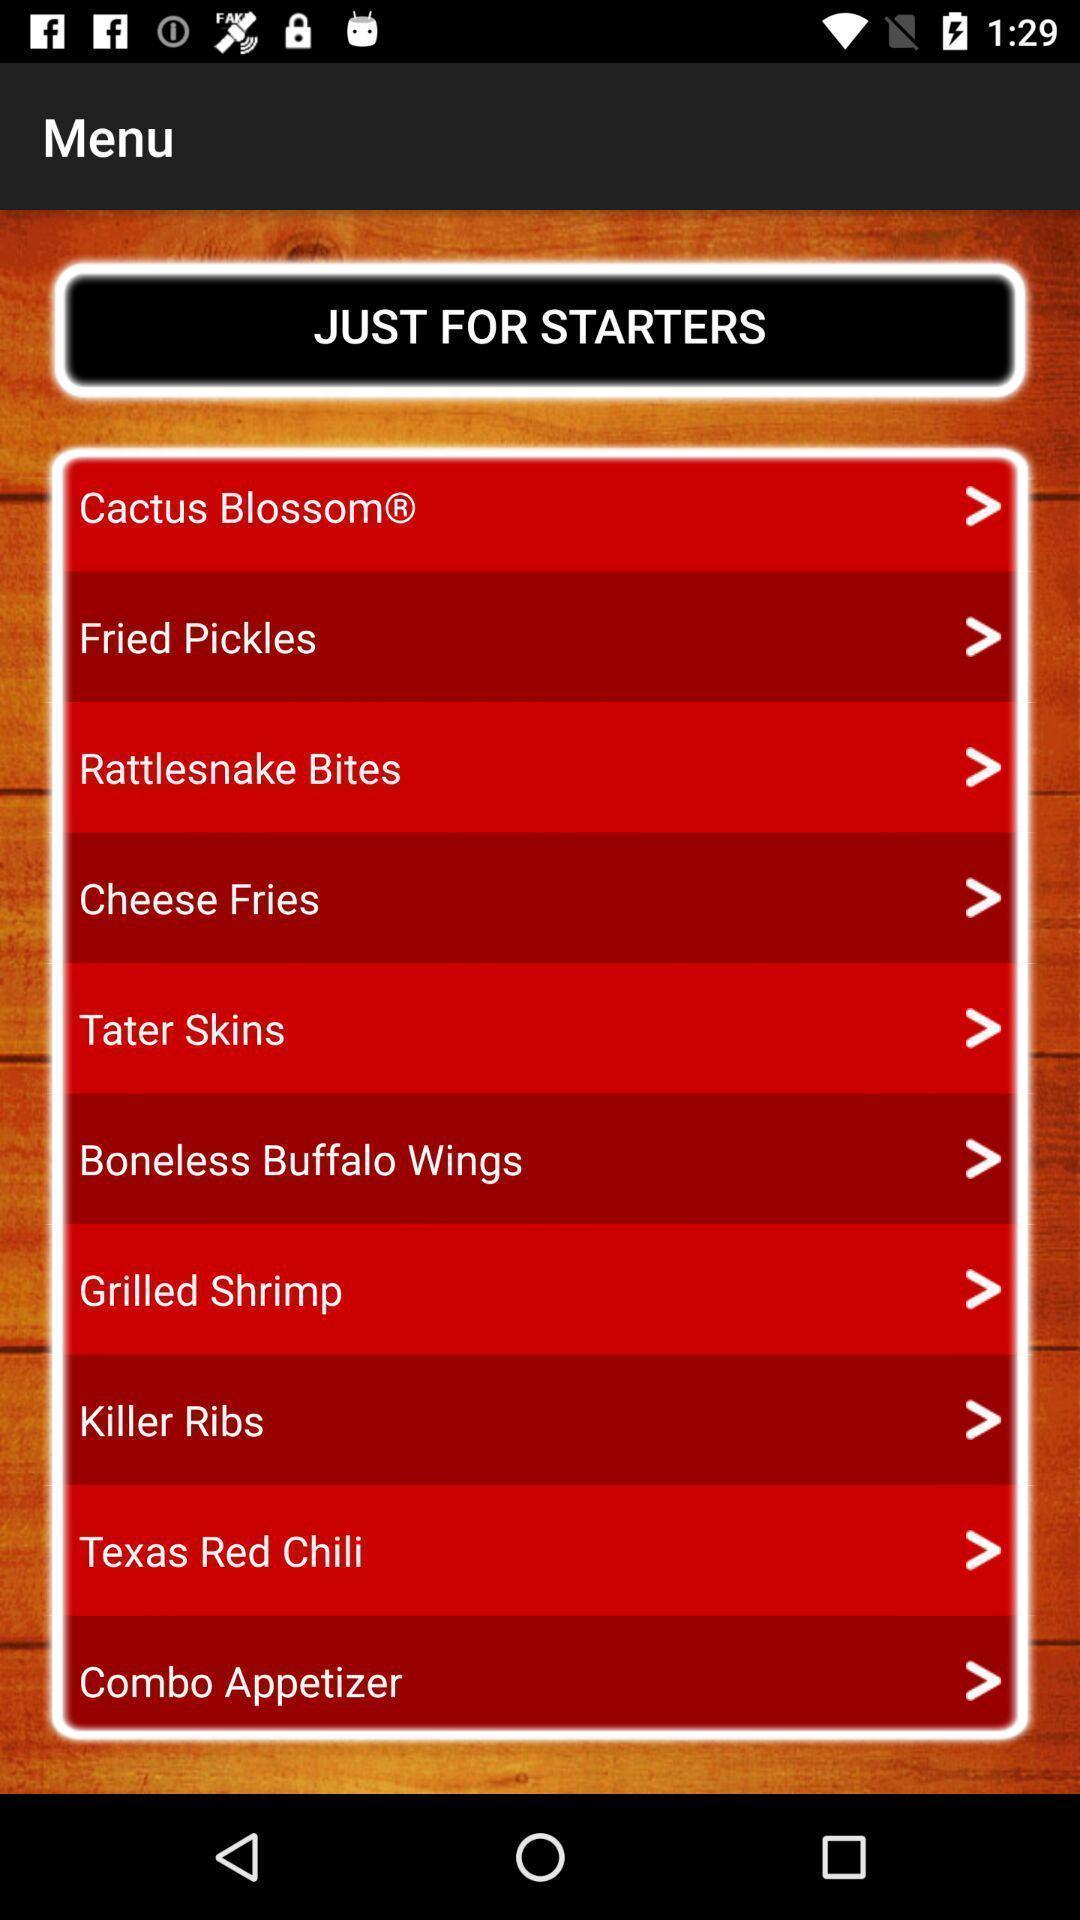Explain the elements present in this screenshot. Page showing starters. 